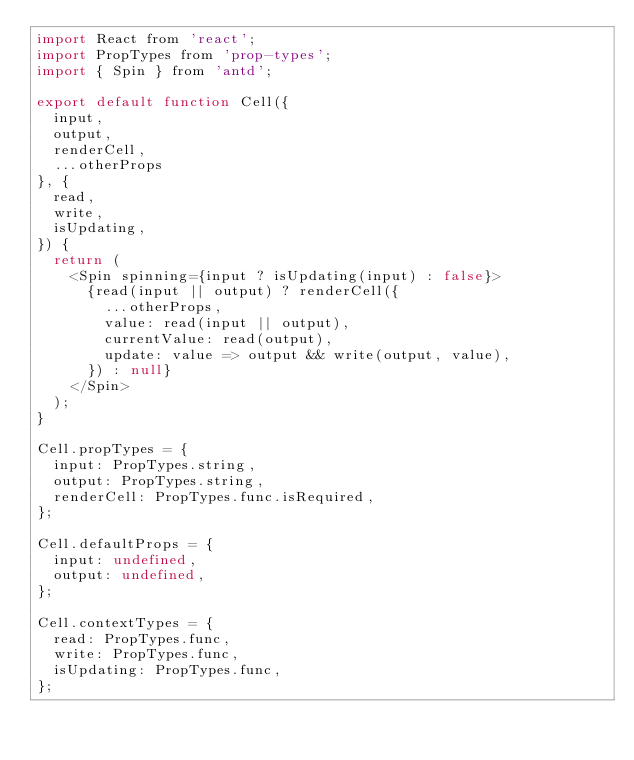Convert code to text. <code><loc_0><loc_0><loc_500><loc_500><_JavaScript_>import React from 'react';
import PropTypes from 'prop-types';
import { Spin } from 'antd';

export default function Cell({
  input,
  output,
  renderCell,
  ...otherProps
}, {
  read,
  write,
  isUpdating,
}) {
  return (
    <Spin spinning={input ? isUpdating(input) : false}>
      {read(input || output) ? renderCell({
        ...otherProps,
        value: read(input || output),
        currentValue: read(output),
        update: value => output && write(output, value),
      }) : null}
    </Spin>
  );
}

Cell.propTypes = {
  input: PropTypes.string,
  output: PropTypes.string,
  renderCell: PropTypes.func.isRequired,
};

Cell.defaultProps = {
  input: undefined,
  output: undefined,
};

Cell.contextTypes = {
  read: PropTypes.func,
  write: PropTypes.func,
  isUpdating: PropTypes.func,
};
</code> 